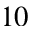<formula> <loc_0><loc_0><loc_500><loc_500>1 0</formula> 